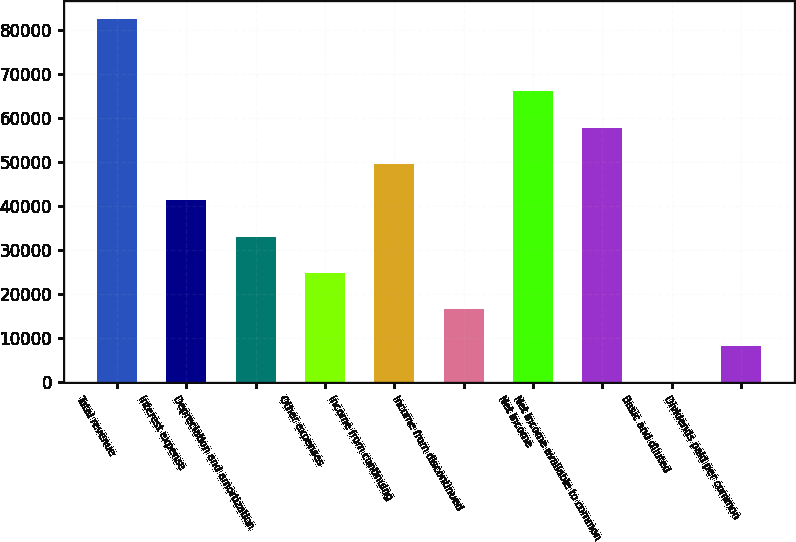Convert chart. <chart><loc_0><loc_0><loc_500><loc_500><bar_chart><fcel>Total revenue<fcel>Interest expense<fcel>Depreciation and amortization<fcel>Other expenses<fcel>Income from continuing<fcel>Income from discontinued<fcel>Net income<fcel>Net income available to common<fcel>Basic and diluted<fcel>Dividends paid per common<nl><fcel>82521<fcel>41260.6<fcel>33008.6<fcel>24756.5<fcel>49512.7<fcel>16504.4<fcel>66016.9<fcel>57764.8<fcel>0.29<fcel>8252.36<nl></chart> 